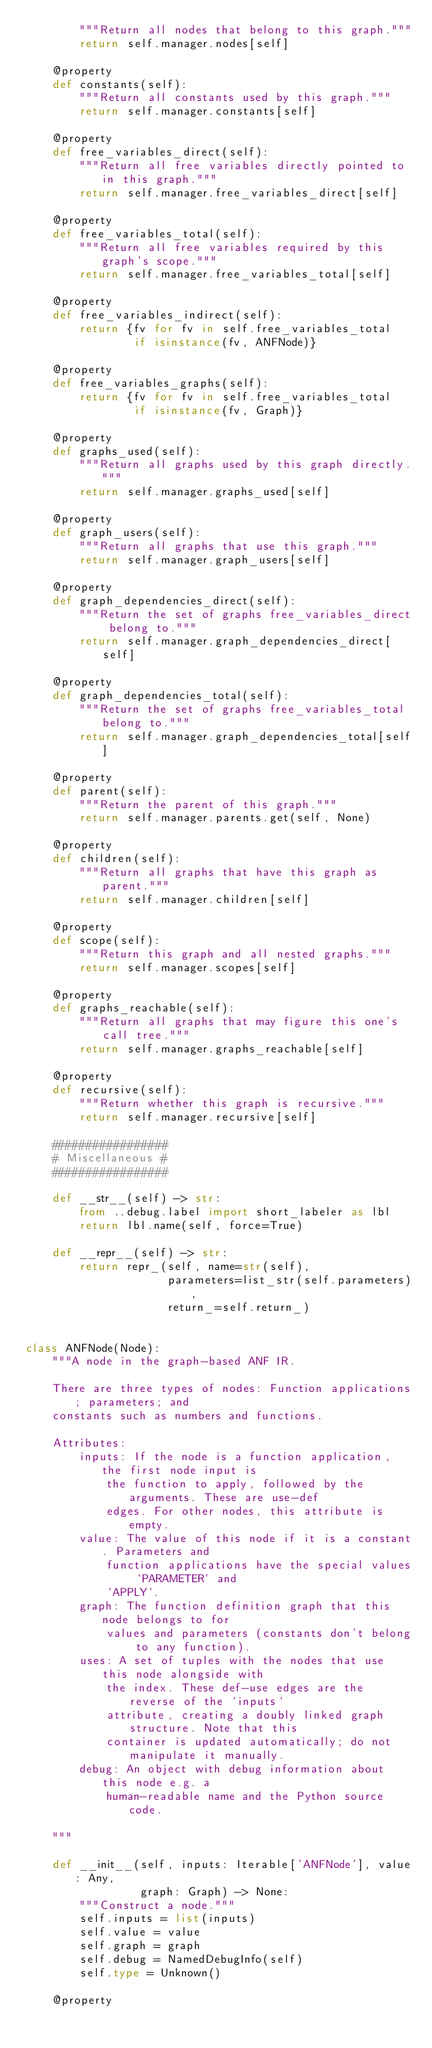Convert code to text. <code><loc_0><loc_0><loc_500><loc_500><_Python_>        """Return all nodes that belong to this graph."""
        return self.manager.nodes[self]

    @property
    def constants(self):
        """Return all constants used by this graph."""
        return self.manager.constants[self]

    @property
    def free_variables_direct(self):
        """Return all free variables directly pointed to in this graph."""
        return self.manager.free_variables_direct[self]

    @property
    def free_variables_total(self):
        """Return all free variables required by this graph's scope."""
        return self.manager.free_variables_total[self]

    @property
    def free_variables_indirect(self):
        return {fv for fv in self.free_variables_total
                if isinstance(fv, ANFNode)}

    @property
    def free_variables_graphs(self):
        return {fv for fv in self.free_variables_total
                if isinstance(fv, Graph)}

    @property
    def graphs_used(self):
        """Return all graphs used by this graph directly."""
        return self.manager.graphs_used[self]

    @property
    def graph_users(self):
        """Return all graphs that use this graph."""
        return self.manager.graph_users[self]

    @property
    def graph_dependencies_direct(self):
        """Return the set of graphs free_variables_direct belong to."""
        return self.manager.graph_dependencies_direct[self]

    @property
    def graph_dependencies_total(self):
        """Return the set of graphs free_variables_total belong to."""
        return self.manager.graph_dependencies_total[self]

    @property
    def parent(self):
        """Return the parent of this graph."""
        return self.manager.parents.get(self, None)

    @property
    def children(self):
        """Return all graphs that have this graph as parent."""
        return self.manager.children[self]

    @property
    def scope(self):
        """Return this graph and all nested graphs."""
        return self.manager.scopes[self]

    @property
    def graphs_reachable(self):
        """Return all graphs that may figure this one's call tree."""
        return self.manager.graphs_reachable[self]

    @property
    def recursive(self):
        """Return whether this graph is recursive."""
        return self.manager.recursive[self]

    #################
    # Miscellaneous #
    #################

    def __str__(self) -> str:
        from ..debug.label import short_labeler as lbl
        return lbl.name(self, force=True)

    def __repr__(self) -> str:
        return repr_(self, name=str(self),
                     parameters=list_str(self.parameters),
                     return_=self.return_)


class ANFNode(Node):
    """A node in the graph-based ANF IR.

    There are three types of nodes: Function applications; parameters; and
    constants such as numbers and functions.

    Attributes:
        inputs: If the node is a function application, the first node input is
            the function to apply, followed by the arguments. These are use-def
            edges. For other nodes, this attribute is empty.
        value: The value of this node if it is a constant. Parameters and
            function applications have the special values `PARAMETER` and
            `APPLY`.
        graph: The function definition graph that this node belongs to for
            values and parameters (constants don't belong to any function).
        uses: A set of tuples with the nodes that use this node alongside with
            the index. These def-use edges are the reverse of the `inputs`
            attribute, creating a doubly linked graph structure. Note that this
            container is updated automatically; do not manipulate it manually.
        debug: An object with debug information about this node e.g. a
            human-readable name and the Python source code.

    """

    def __init__(self, inputs: Iterable['ANFNode'], value: Any,
                 graph: Graph) -> None:
        """Construct a node."""
        self.inputs = list(inputs)
        self.value = value
        self.graph = graph
        self.debug = NamedDebugInfo(self)
        self.type = Unknown()

    @property</code> 